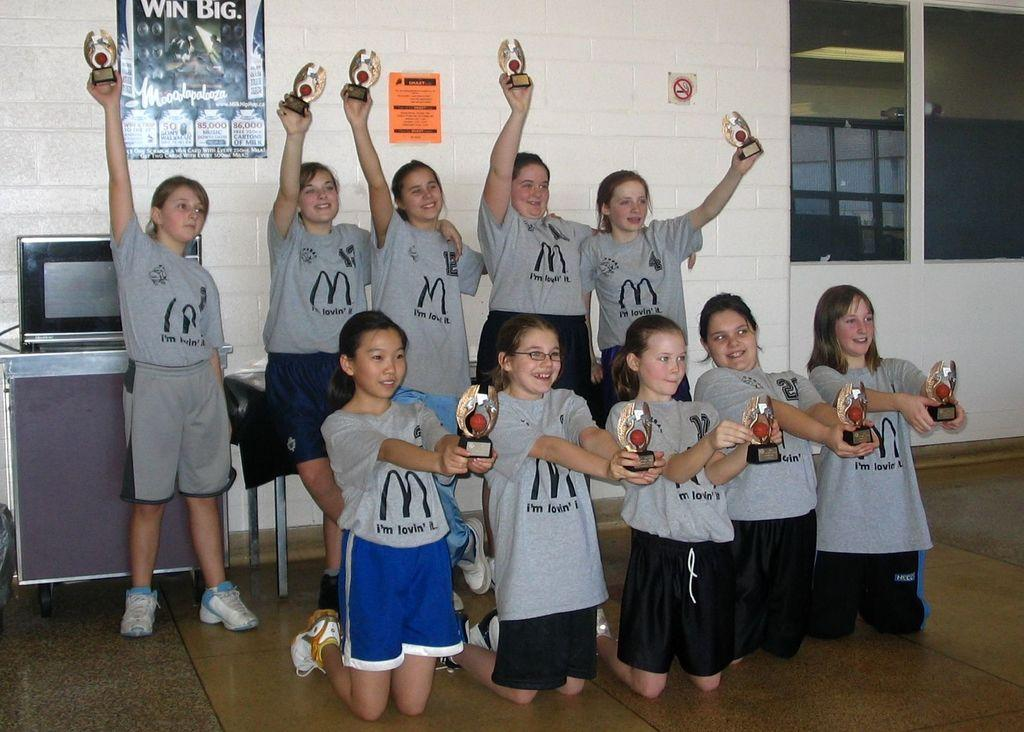<image>
Create a compact narrative representing the image presented. A group of kids holding up trophies and wearing shirts that have a M on it 